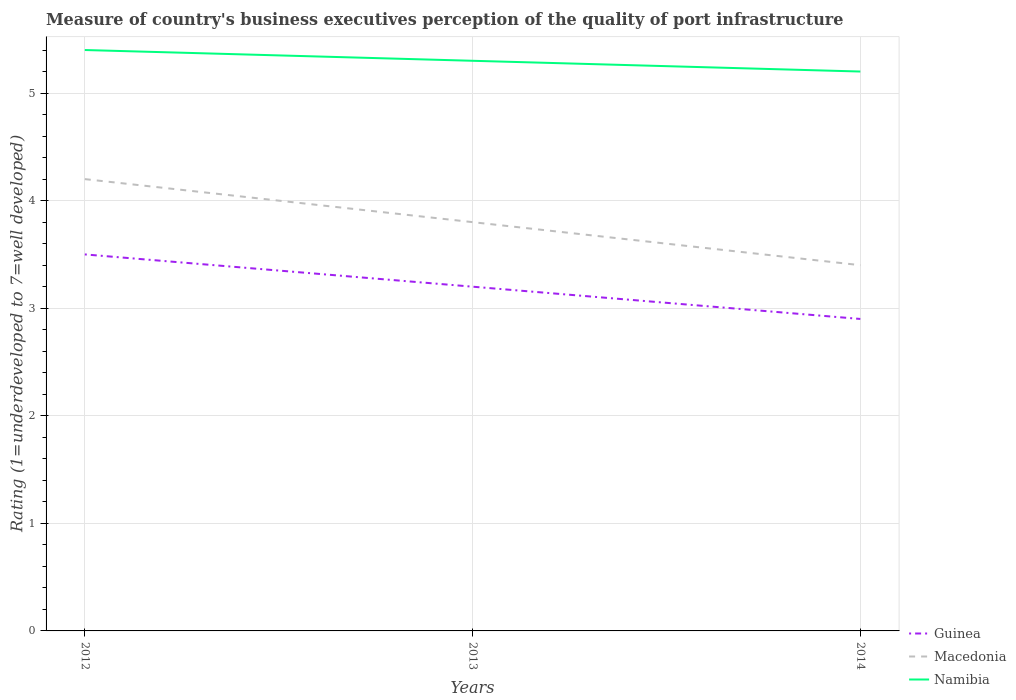Is the number of lines equal to the number of legend labels?
Provide a short and direct response. Yes. What is the total ratings of the quality of port infrastructure in Guinea in the graph?
Offer a very short reply. 0.6. What is the difference between the highest and the second highest ratings of the quality of port infrastructure in Guinea?
Make the answer very short. 0.6. Is the ratings of the quality of port infrastructure in Guinea strictly greater than the ratings of the quality of port infrastructure in Namibia over the years?
Offer a terse response. Yes. How many lines are there?
Provide a succinct answer. 3. How many years are there in the graph?
Your answer should be compact. 3. What is the difference between two consecutive major ticks on the Y-axis?
Provide a succinct answer. 1. Are the values on the major ticks of Y-axis written in scientific E-notation?
Give a very brief answer. No. Does the graph contain grids?
Your answer should be compact. Yes. Where does the legend appear in the graph?
Offer a terse response. Bottom right. What is the title of the graph?
Keep it short and to the point. Measure of country's business executives perception of the quality of port infrastructure. What is the label or title of the Y-axis?
Offer a very short reply. Rating (1=underdeveloped to 7=well developed). What is the Rating (1=underdeveloped to 7=well developed) of Guinea in 2012?
Provide a succinct answer. 3.5. What is the Rating (1=underdeveloped to 7=well developed) of Guinea in 2014?
Ensure brevity in your answer.  2.9. What is the Rating (1=underdeveloped to 7=well developed) of Namibia in 2014?
Offer a very short reply. 5.2. Across all years, what is the maximum Rating (1=underdeveloped to 7=well developed) of Guinea?
Offer a very short reply. 3.5. Across all years, what is the minimum Rating (1=underdeveloped to 7=well developed) in Namibia?
Your response must be concise. 5.2. What is the total Rating (1=underdeveloped to 7=well developed) in Macedonia in the graph?
Your answer should be compact. 11.4. What is the difference between the Rating (1=underdeveloped to 7=well developed) of Guinea in 2012 and that in 2013?
Offer a terse response. 0.3. What is the difference between the Rating (1=underdeveloped to 7=well developed) of Macedonia in 2012 and that in 2013?
Ensure brevity in your answer.  0.4. What is the difference between the Rating (1=underdeveloped to 7=well developed) in Namibia in 2012 and that in 2013?
Ensure brevity in your answer.  0.1. What is the difference between the Rating (1=underdeveloped to 7=well developed) of Guinea in 2012 and that in 2014?
Offer a very short reply. 0.6. What is the difference between the Rating (1=underdeveloped to 7=well developed) in Macedonia in 2012 and that in 2014?
Give a very brief answer. 0.8. What is the difference between the Rating (1=underdeveloped to 7=well developed) of Guinea in 2013 and that in 2014?
Give a very brief answer. 0.3. What is the difference between the Rating (1=underdeveloped to 7=well developed) of Namibia in 2013 and that in 2014?
Your answer should be very brief. 0.1. What is the difference between the Rating (1=underdeveloped to 7=well developed) in Guinea in 2013 and the Rating (1=underdeveloped to 7=well developed) in Namibia in 2014?
Provide a succinct answer. -2. What is the average Rating (1=underdeveloped to 7=well developed) of Guinea per year?
Give a very brief answer. 3.2. What is the average Rating (1=underdeveloped to 7=well developed) of Macedonia per year?
Offer a very short reply. 3.8. What is the average Rating (1=underdeveloped to 7=well developed) in Namibia per year?
Your response must be concise. 5.3. In the year 2012, what is the difference between the Rating (1=underdeveloped to 7=well developed) in Guinea and Rating (1=underdeveloped to 7=well developed) in Macedonia?
Make the answer very short. -0.7. In the year 2012, what is the difference between the Rating (1=underdeveloped to 7=well developed) of Guinea and Rating (1=underdeveloped to 7=well developed) of Namibia?
Your answer should be compact. -1.9. In the year 2013, what is the difference between the Rating (1=underdeveloped to 7=well developed) of Guinea and Rating (1=underdeveloped to 7=well developed) of Namibia?
Keep it short and to the point. -2.1. In the year 2014, what is the difference between the Rating (1=underdeveloped to 7=well developed) of Guinea and Rating (1=underdeveloped to 7=well developed) of Namibia?
Keep it short and to the point. -2.3. In the year 2014, what is the difference between the Rating (1=underdeveloped to 7=well developed) of Macedonia and Rating (1=underdeveloped to 7=well developed) of Namibia?
Your response must be concise. -1.8. What is the ratio of the Rating (1=underdeveloped to 7=well developed) in Guinea in 2012 to that in 2013?
Your answer should be compact. 1.09. What is the ratio of the Rating (1=underdeveloped to 7=well developed) in Macedonia in 2012 to that in 2013?
Offer a very short reply. 1.11. What is the ratio of the Rating (1=underdeveloped to 7=well developed) of Namibia in 2012 to that in 2013?
Provide a succinct answer. 1.02. What is the ratio of the Rating (1=underdeveloped to 7=well developed) in Guinea in 2012 to that in 2014?
Provide a short and direct response. 1.21. What is the ratio of the Rating (1=underdeveloped to 7=well developed) of Macedonia in 2012 to that in 2014?
Your answer should be compact. 1.24. What is the ratio of the Rating (1=underdeveloped to 7=well developed) in Guinea in 2013 to that in 2014?
Offer a very short reply. 1.1. What is the ratio of the Rating (1=underdeveloped to 7=well developed) in Macedonia in 2013 to that in 2014?
Provide a succinct answer. 1.12. What is the ratio of the Rating (1=underdeveloped to 7=well developed) in Namibia in 2013 to that in 2014?
Provide a short and direct response. 1.02. What is the difference between the highest and the second highest Rating (1=underdeveloped to 7=well developed) of Namibia?
Ensure brevity in your answer.  0.1. What is the difference between the highest and the lowest Rating (1=underdeveloped to 7=well developed) in Macedonia?
Provide a short and direct response. 0.8. What is the difference between the highest and the lowest Rating (1=underdeveloped to 7=well developed) in Namibia?
Provide a succinct answer. 0.2. 